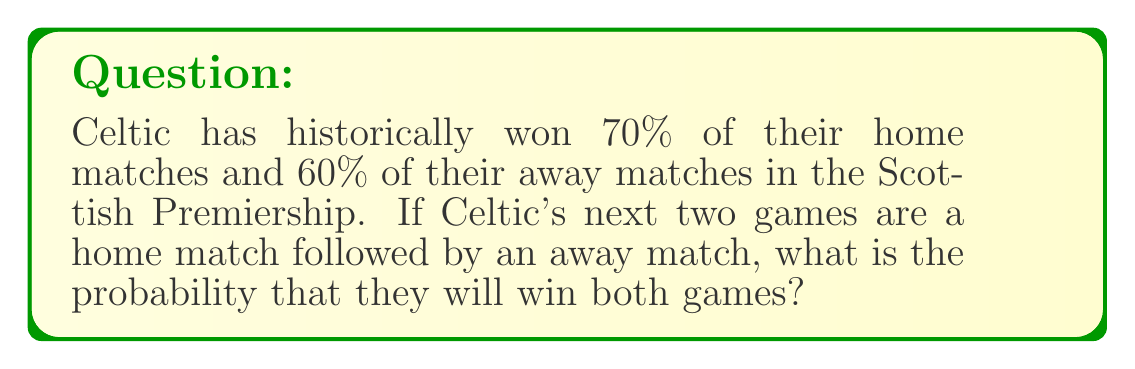Could you help me with this problem? To solve this problem, we need to use the concept of independent events and multiply their individual probabilities.

1. Probability of winning the home match: $p_h = 0.70$
2. Probability of winning the away match: $p_a = 0.60$

Since these are independent events (the outcome of one match doesn't affect the other), we multiply their probabilities:

$$P(\text{win both}) = p_h \times p_a$$

Substituting the values:

$$P(\text{win both}) = 0.70 \times 0.60$$

Calculate:

$$P(\text{win both}) = 0.42$$

Therefore, the probability of Celtic winning both matches is 0.42 or 42%.
Answer: $0.42$ or $42\%$ 